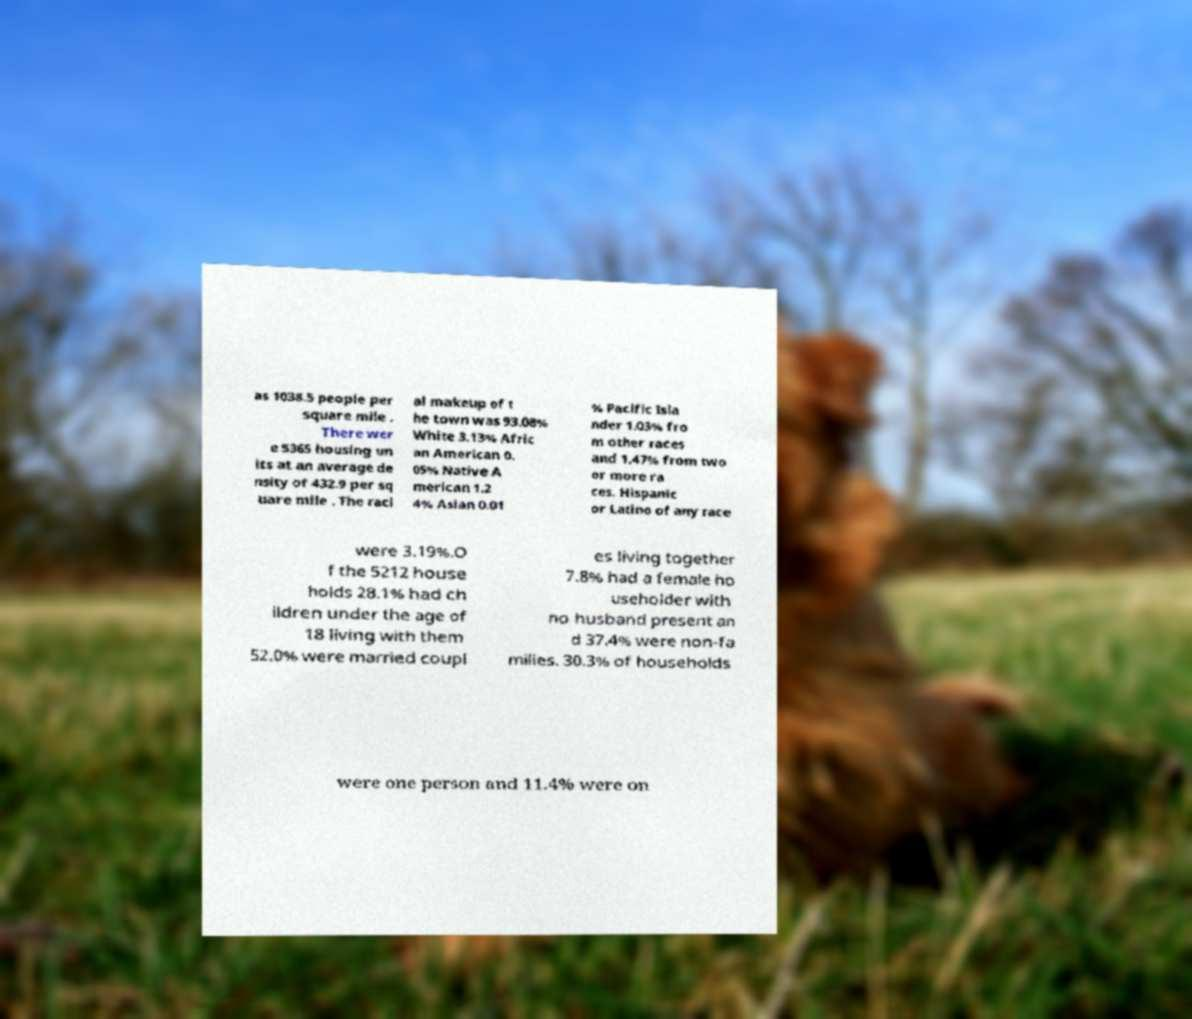Please read and relay the text visible in this image. What does it say? as 1038.5 people per square mile . There wer e 5365 housing un its at an average de nsity of 432.9 per sq uare mile . The raci al makeup of t he town was 93.08% White 3.13% Afric an American 0. 05% Native A merican 1.2 4% Asian 0.01 % Pacific Isla nder 1.03% fro m other races and 1.47% from two or more ra ces. Hispanic or Latino of any race were 3.19%.O f the 5212 house holds 28.1% had ch ildren under the age of 18 living with them 52.0% were married coupl es living together 7.8% had a female ho useholder with no husband present an d 37.4% were non-fa milies. 30.3% of households were one person and 11.4% were on 